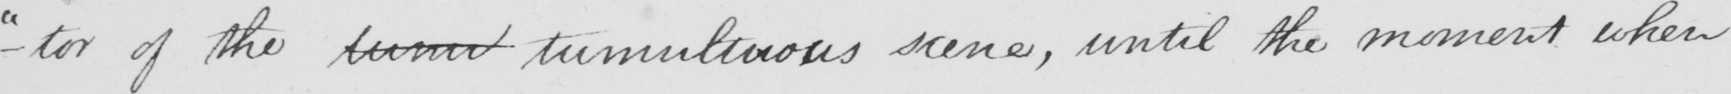Can you tell me what this handwritten text says? " -tor of the tumil tumultuous scene , until the moment when 